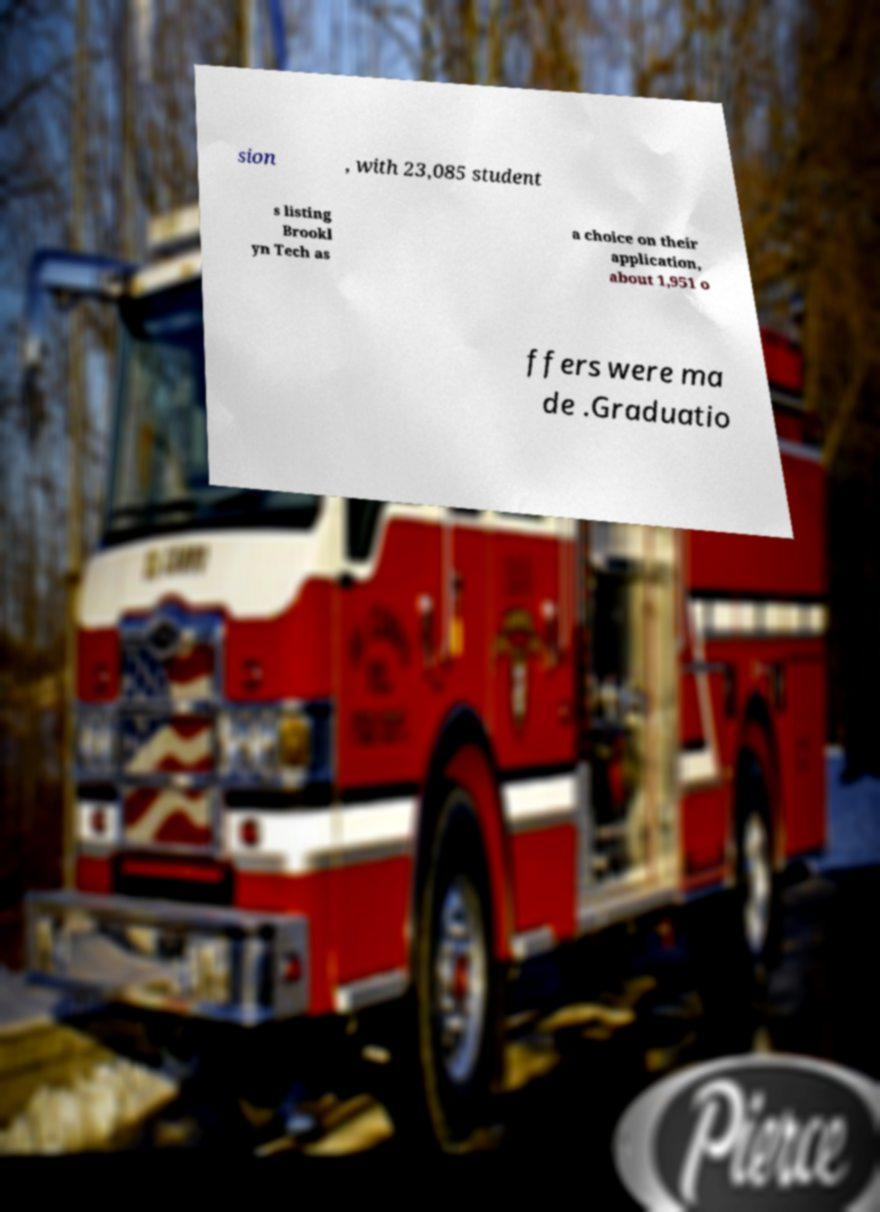Could you assist in decoding the text presented in this image and type it out clearly? sion , with 23,085 student s listing Brookl yn Tech as a choice on their application, about 1,951 o ffers were ma de .Graduatio 